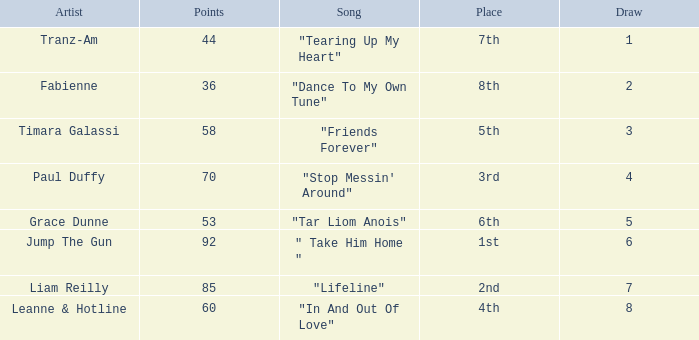What's the total number of points for grace dunne with a draw over 5? 0.0. 